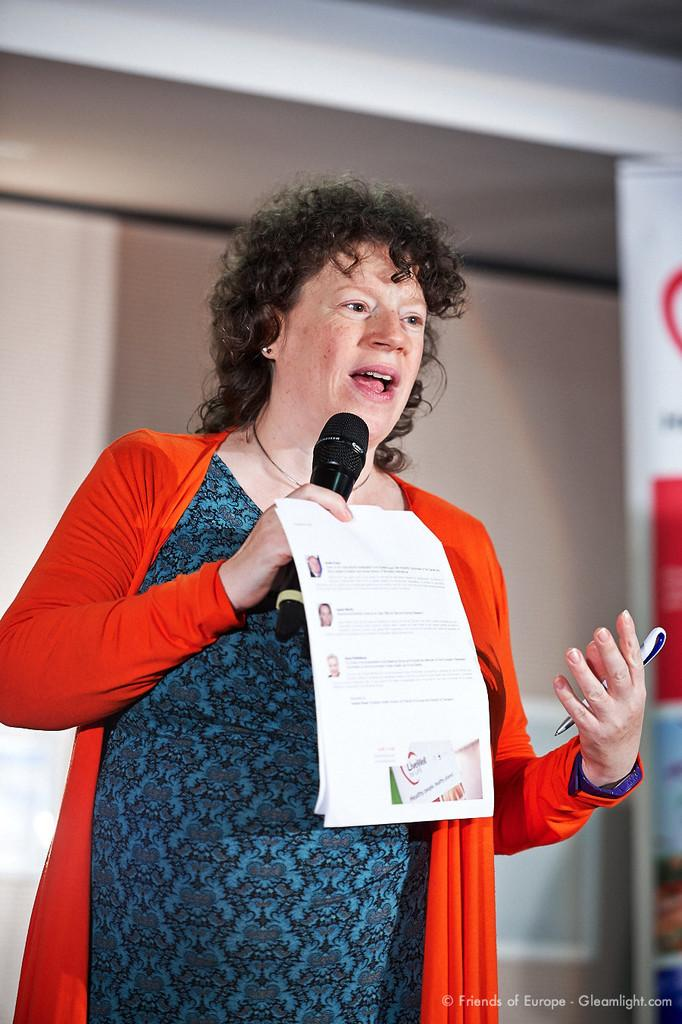Who is the main subject in the image? There is a lady in the image. What is the lady wearing? The lady is wearing a blue dress and a red jacket. What objects is the lady holding in her hands? The lady is holding a mic, a paper, and a pen in her hands. What is the lady doing in the image? The lady is talking. What type of pest can be seen crawling on the lady's shoulder in the image? There are no pests visible in the image; the image only shows the lady and the objects she is holding. 